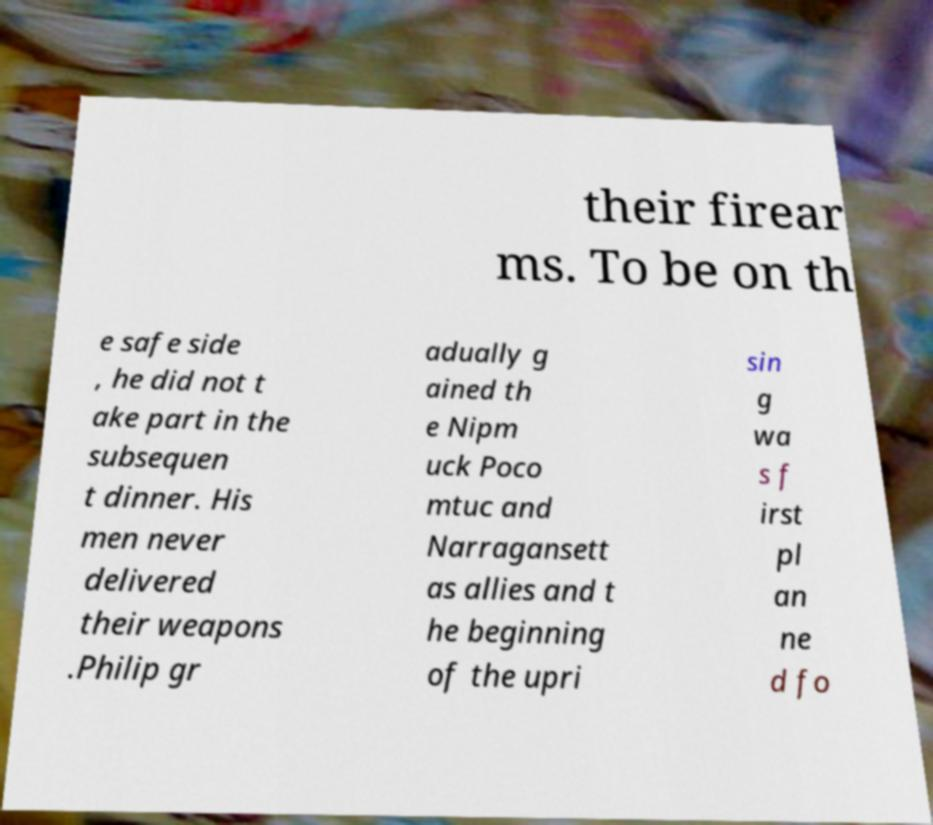There's text embedded in this image that I need extracted. Can you transcribe it verbatim? their firear ms. To be on th e safe side , he did not t ake part in the subsequen t dinner. His men never delivered their weapons .Philip gr adually g ained th e Nipm uck Poco mtuc and Narragansett as allies and t he beginning of the upri sin g wa s f irst pl an ne d fo 